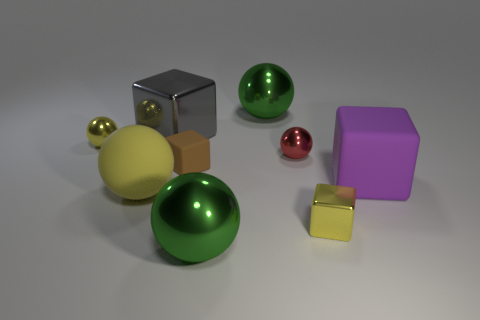What is the color of the big sphere that is in front of the large gray metal block and right of the gray cube?
Give a very brief answer. Green. What number of things are either tiny brown cubes or green balls?
Your response must be concise. 3. What number of large objects are yellow metal cubes or green objects?
Offer a very short reply. 2. Are there any other things that are the same color as the large matte sphere?
Offer a terse response. Yes. What is the size of the sphere that is left of the brown matte object and behind the small brown object?
Give a very brief answer. Small. There is a large ball that is on the left side of the brown cube; is it the same color as the small metallic thing left of the brown rubber thing?
Offer a terse response. Yes. How many other things are the same material as the gray cube?
Provide a succinct answer. 5. There is a big object that is both to the left of the small rubber object and in front of the large gray object; what is its shape?
Offer a very short reply. Sphere. Do the large rubber sphere and the large ball that is behind the small yellow shiny sphere have the same color?
Your answer should be compact. No. Is the size of the green thing in front of the brown cube the same as the red sphere?
Your response must be concise. No. 